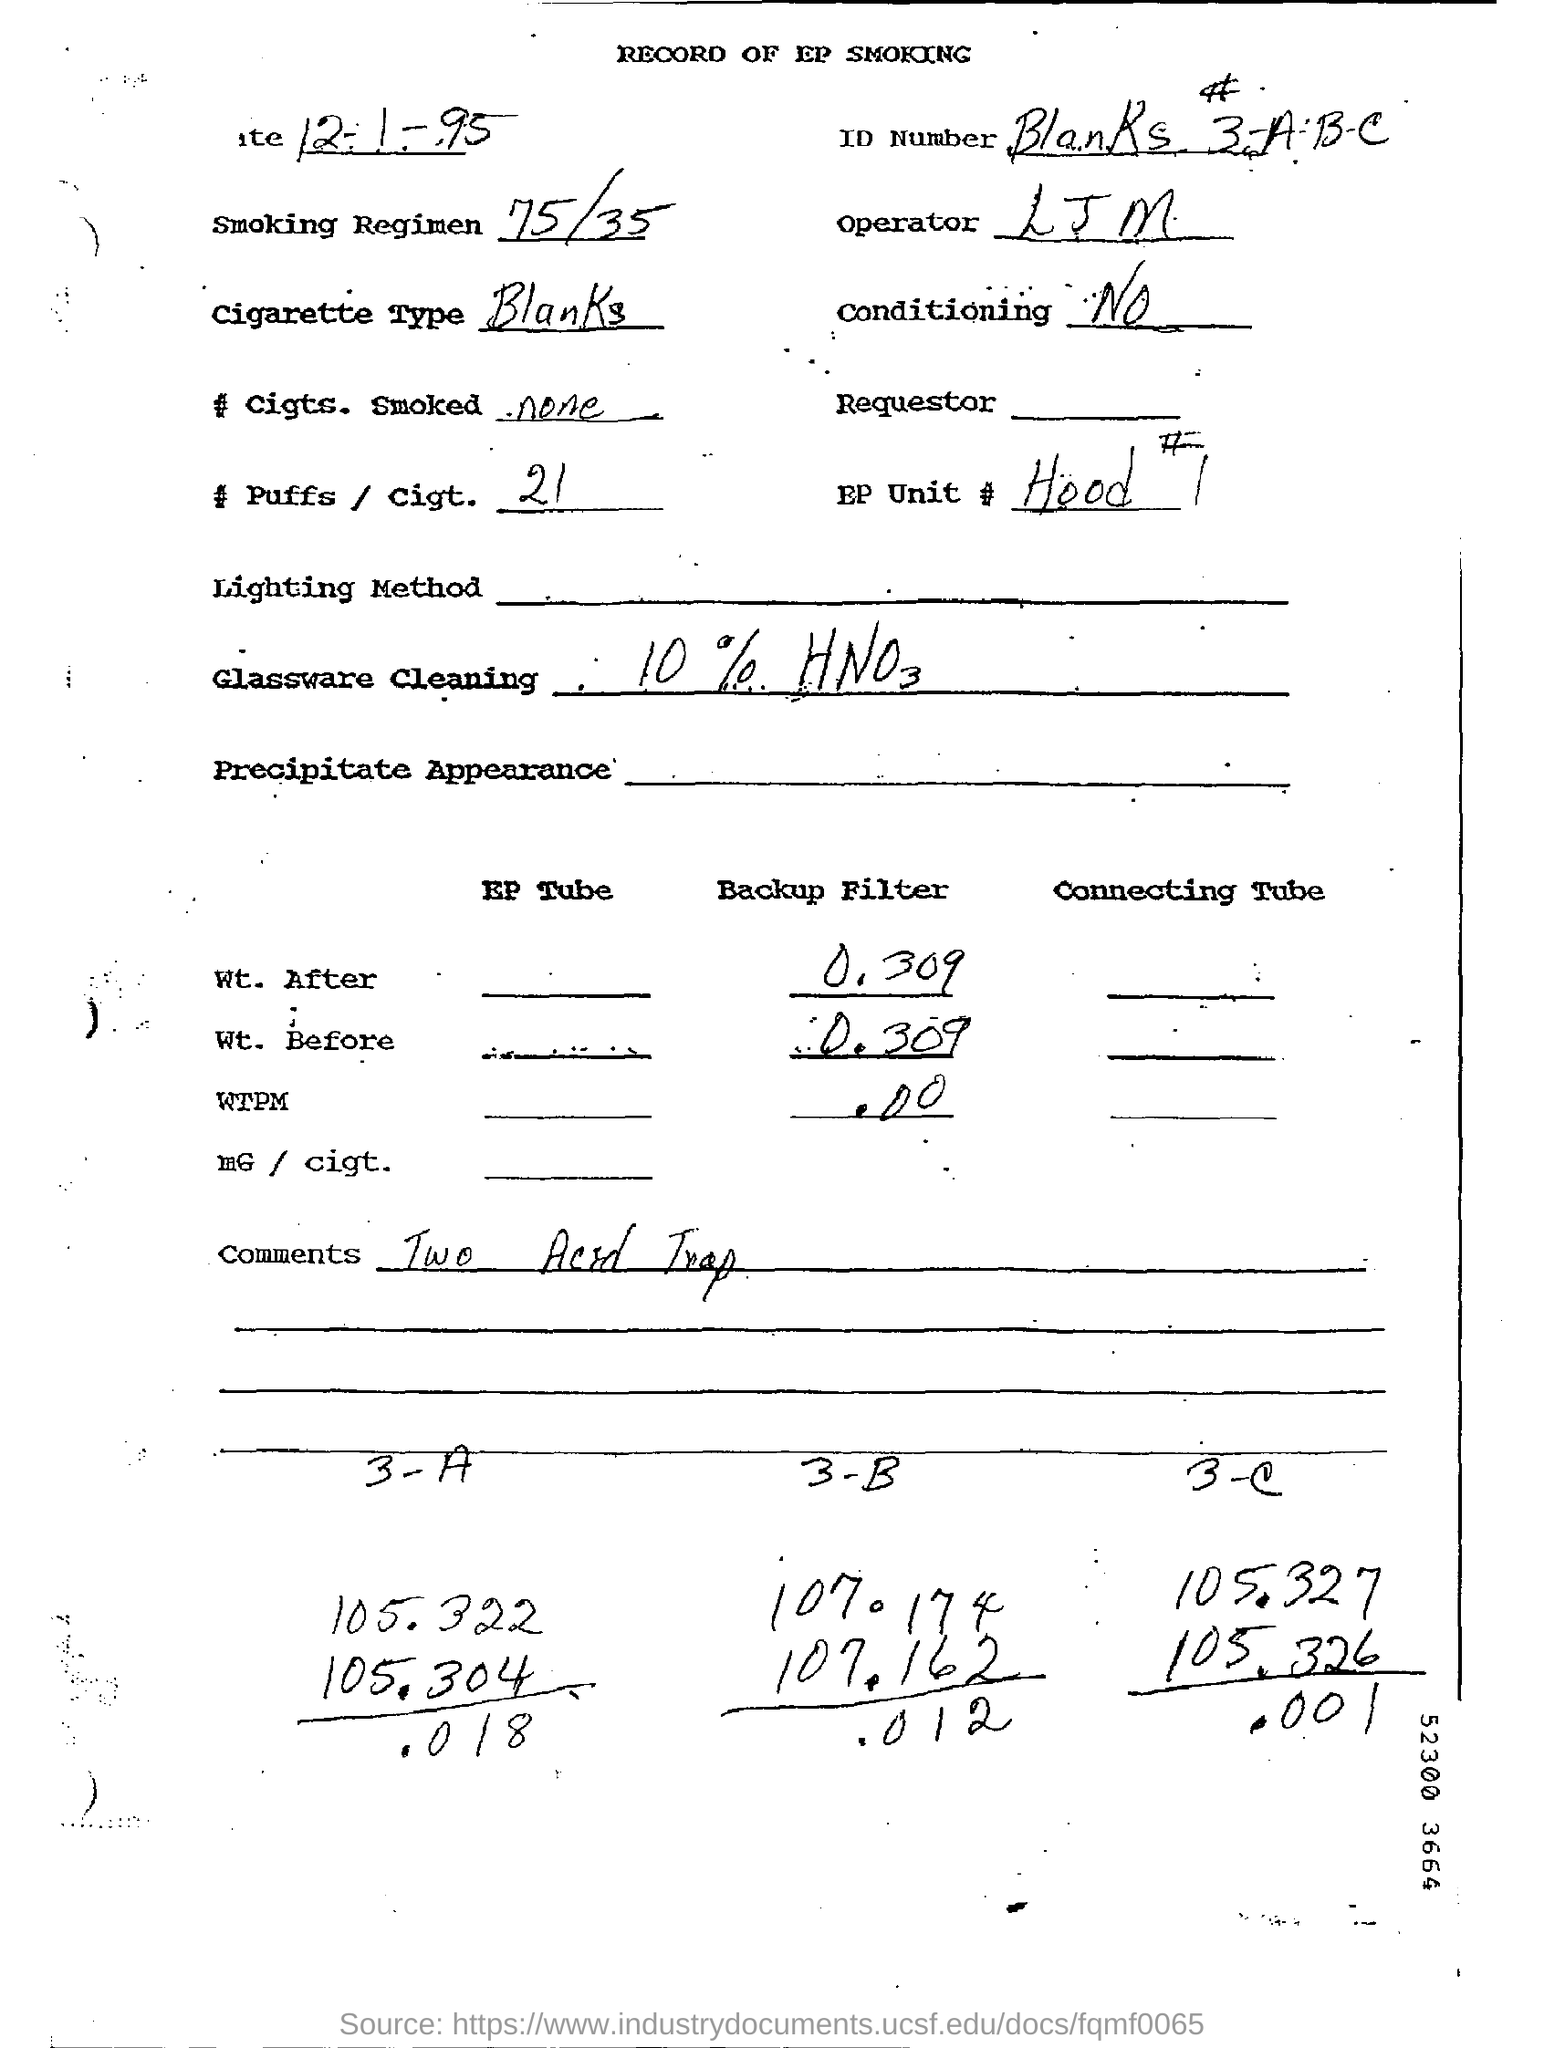What is the cigarette Type ?
Ensure brevity in your answer.  Blanks. What is the Backup filter weight after ?
Keep it short and to the point. 0.309. What is the comment written ?
Provide a short and direct response. Two Acid Trap. What is the number of puffs/cigt. ?
Provide a succinct answer. 21. What is the smoking Regimen ?
Keep it short and to the point. 75/35. 